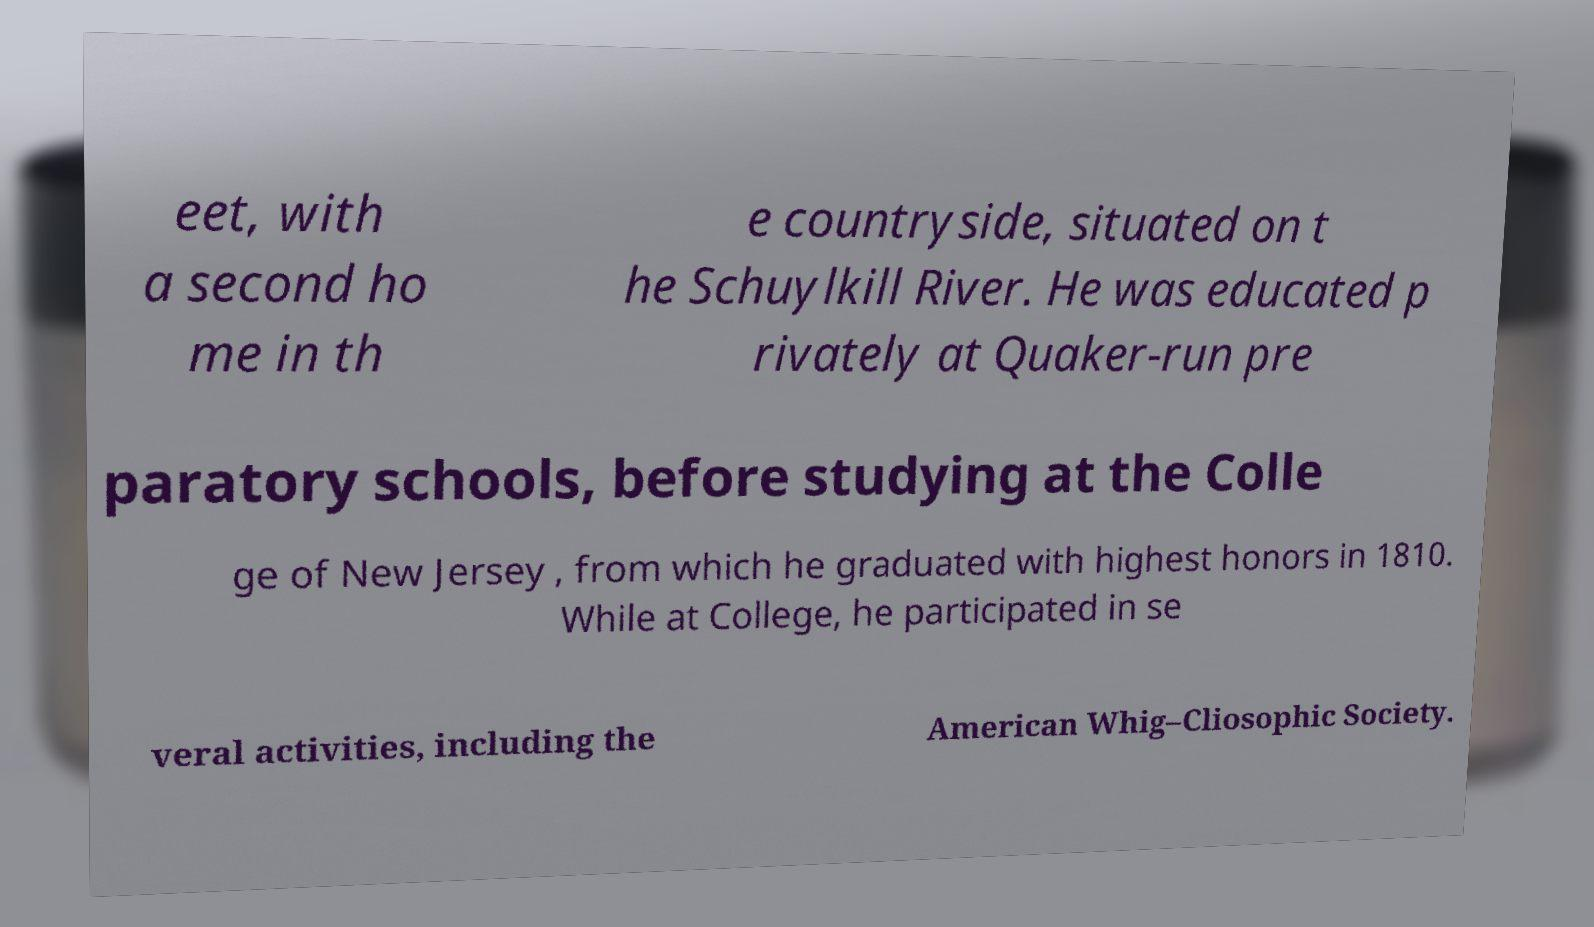Could you extract and type out the text from this image? eet, with a second ho me in th e countryside, situated on t he Schuylkill River. He was educated p rivately at Quaker-run pre paratory schools, before studying at the Colle ge of New Jersey , from which he graduated with highest honors in 1810. While at College, he participated in se veral activities, including the American Whig–Cliosophic Society. 